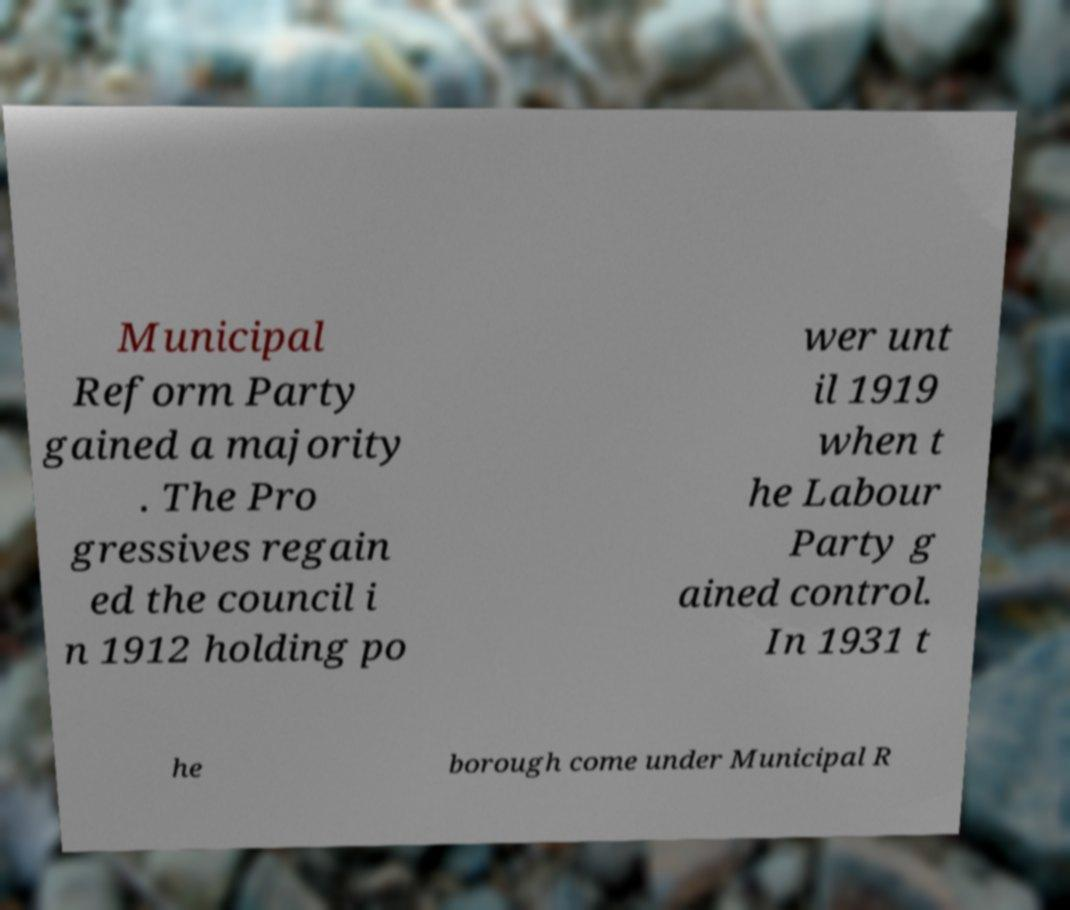Please read and relay the text visible in this image. What does it say? Municipal Reform Party gained a majority . The Pro gressives regain ed the council i n 1912 holding po wer unt il 1919 when t he Labour Party g ained control. In 1931 t he borough come under Municipal R 